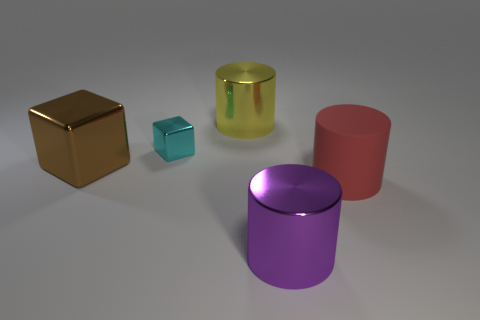Is there a large rubber thing that has the same color as the large cube?
Offer a terse response. No. What number of tiny things are cyan rubber things or yellow cylinders?
Your response must be concise. 0. How many large red things are there?
Your response must be concise. 1. There is a cylinder that is behind the big red cylinder; what is its material?
Your response must be concise. Metal. There is a yellow object; are there any purple shiny cylinders on the left side of it?
Keep it short and to the point. No. Is the purple cylinder the same size as the brown metallic block?
Your response must be concise. Yes. What number of large red cylinders are the same material as the cyan cube?
Provide a short and direct response. 0. What is the size of the metal cylinder on the left side of the big thing in front of the big matte cylinder?
Offer a terse response. Large. There is a big object that is both on the left side of the red rubber cylinder and in front of the large shiny cube; what is its color?
Offer a very short reply. Purple. Is the shape of the small metal object the same as the big purple metal thing?
Your answer should be very brief. No. 